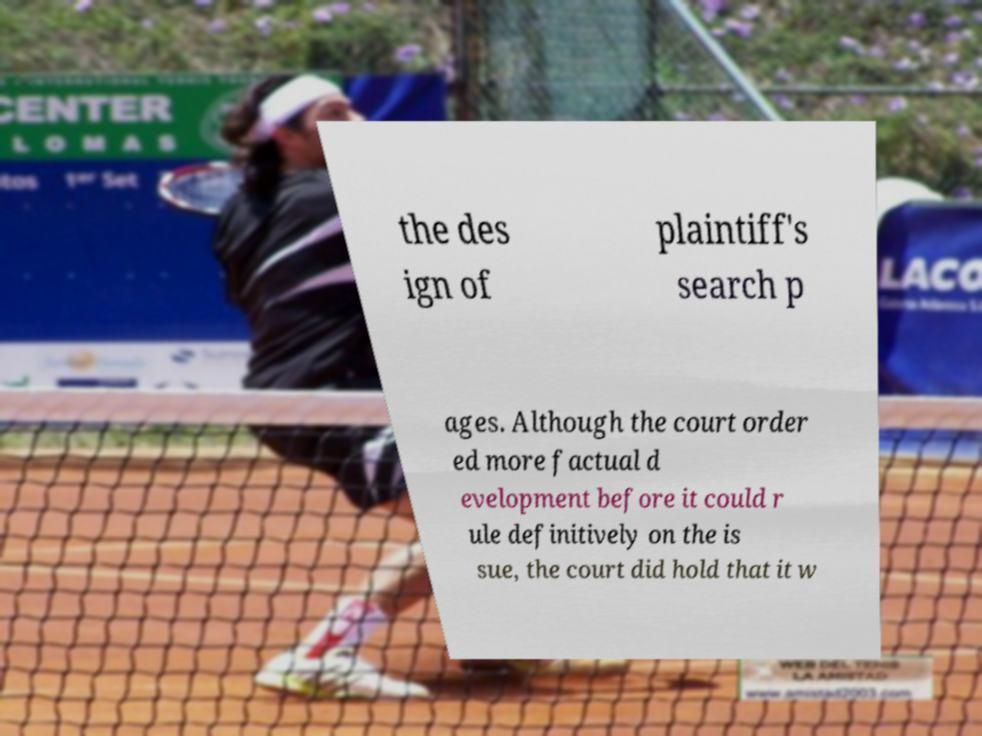There's text embedded in this image that I need extracted. Can you transcribe it verbatim? the des ign of plaintiff's search p ages. Although the court order ed more factual d evelopment before it could r ule definitively on the is sue, the court did hold that it w 